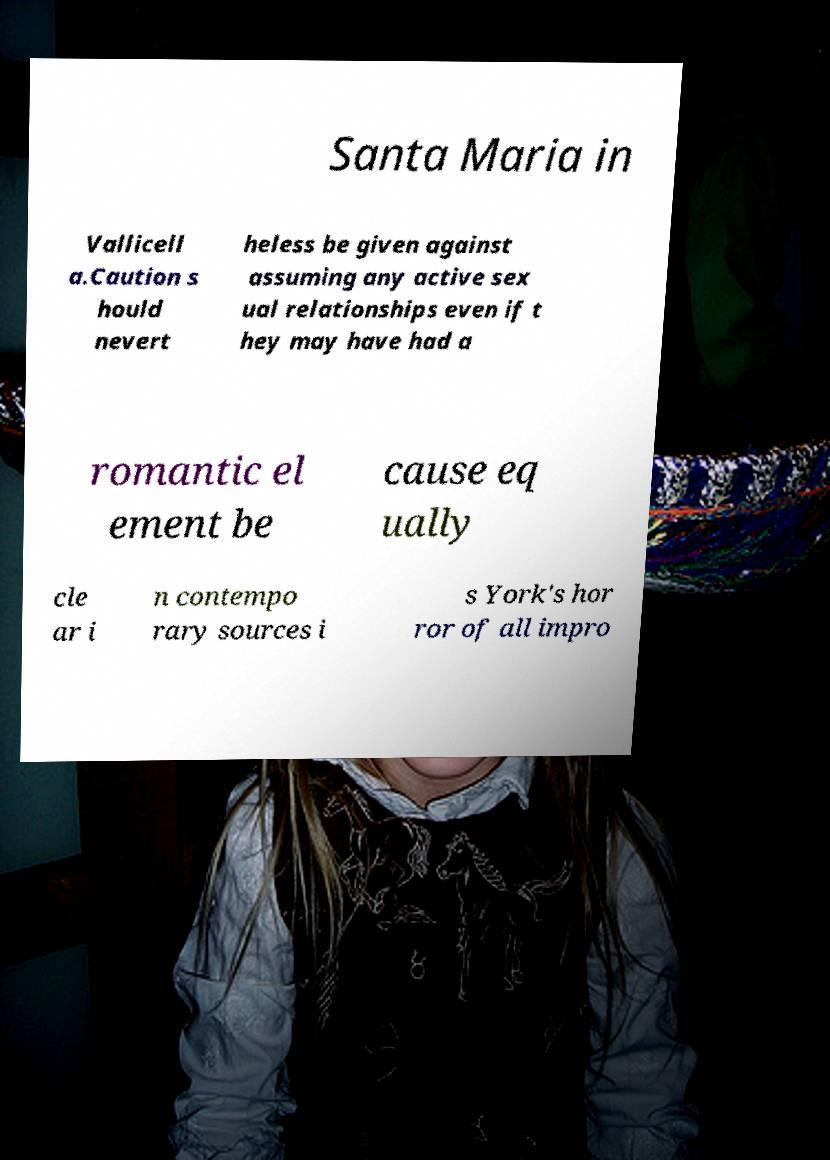Could you assist in decoding the text presented in this image and type it out clearly? Santa Maria in Vallicell a.Caution s hould nevert heless be given against assuming any active sex ual relationships even if t hey may have had a romantic el ement be cause eq ually cle ar i n contempo rary sources i s York's hor ror of all impro 